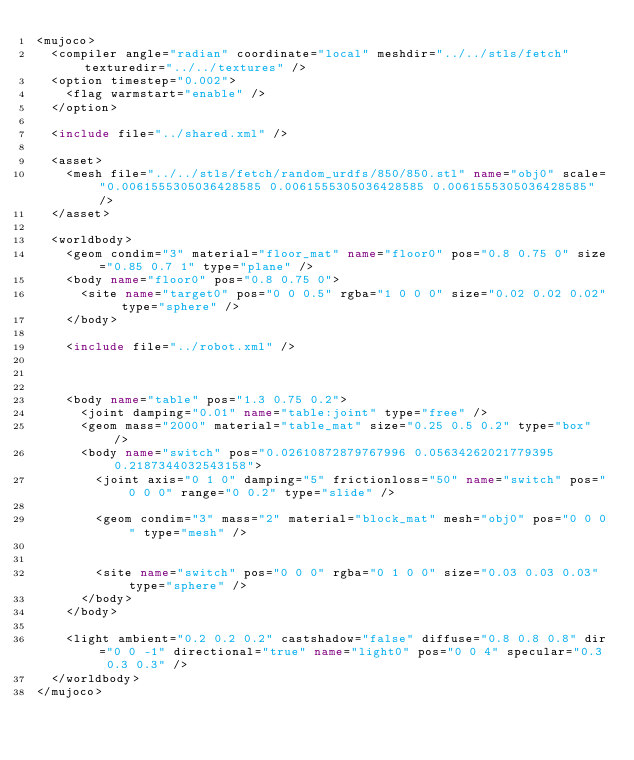<code> <loc_0><loc_0><loc_500><loc_500><_XML_><mujoco>
	<compiler angle="radian" coordinate="local" meshdir="../../stls/fetch" texturedir="../../textures" />
	<option timestep="0.002">
		<flag warmstart="enable" />
	</option>

	<include file="../shared.xml" />

	<asset>
		<mesh file="../../stls/fetch/random_urdfs/850/850.stl" name="obj0" scale="0.0061555305036428585 0.0061555305036428585 0.0061555305036428585" />
	</asset>

	<worldbody>
		<geom condim="3" material="floor_mat" name="floor0" pos="0.8 0.75 0" size="0.85 0.7 1" type="plane" />
		<body name="floor0" pos="0.8 0.75 0">
			<site name="target0" pos="0 0 0.5" rgba="1 0 0 0" size="0.02 0.02 0.02" type="sphere" />
		</body>

		<include file="../robot.xml" />

		

		<body name="table" pos="1.3 0.75 0.2">
			<joint damping="0.01" name="table:joint" type="free" />
			<geom mass="2000" material="table_mat" size="0.25 0.5 0.2" type="box" />
			<body name="switch" pos="0.02610872879767996 0.05634262021779395 0.2187344032543158">
		    <joint axis="0 1 0" damping="5" frictionloss="50" name="switch" pos="0 0 0" range="0 0.2" type="slide" />
				
				<geom condim="3" mass="2" material="block_mat" mesh="obj0" pos="0 0 0" type="mesh" />
				
				
				<site name="switch" pos="0 0 0" rgba="0 1 0 0" size="0.03 0.03 0.03" type="sphere" />
			</body>
    </body>

		<light ambient="0.2 0.2 0.2" castshadow="false" diffuse="0.8 0.8 0.8" dir="0 0 -1" directional="true" name="light0" pos="0 0 4" specular="0.3 0.3 0.3" />
	</worldbody>
</mujoco></code> 